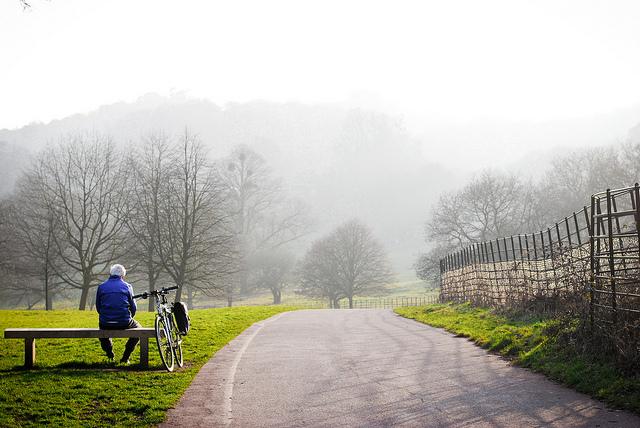Is there more than one person in the picture?
Short answer required. No. How many benches are there?
Answer briefly. 1. What is the person sitting on?
Quick response, please. Bench. What activity is this person taking a break from?
Be succinct. Biking. 